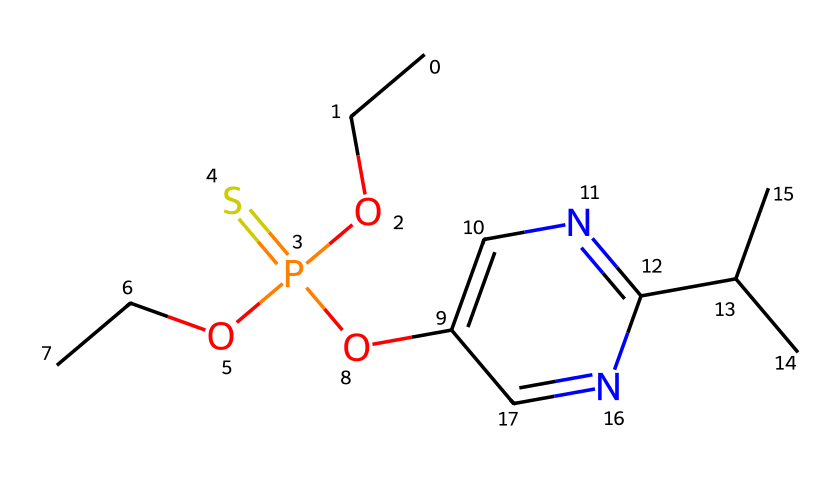How many carbon atoms are present in diazinon? By examining the SMILES representation, we can identify the carbon atoms, which are indicated by the letter "C." Counting all occurrences of "C" (including those in branches), we find there are a total of 10 carbon atoms in the structure.
Answer: 10 What functional group is present in diazinon? In the SMILES, the "O" and "P(=S)" portions indicate the presence of a phosphate functional group. This suggests the chemical belongs to organophosphates, characterized by phosphorus bonded to oxygen.
Answer: phosphate How many nitrogen atoms are present in diazinon? The "n" in the SMILES indicates nitrogen atoms. Observing the structure, we see there are two occurrences of "n," leading us to conclude that there are 2 nitrogen atoms.
Answer: 2 What is the molecular formula of diazinon? By counting the elements in the SMILES—10 carbons, 14 hydrogens, 2 nitrogens, 2 oxygens, 1 phosphorus, and 1 sulfur—we can construct the molecular formula. This leads to the conclusion that the molecular formula is C10H14N2O4PS.
Answer: C10H14N2O4PS What type of pesticide is diazinon classified as? Diazinon is classified as an organophosphate pesticide. This classification is based on the presence of the phosphate functional group, which is typical of organophosphate pesticides that inhibit acetylcholinesterase.
Answer: organophosphate What is the significance of the sulfur atom in diazinon? The sulfur atom in the structure typically indicates the presence of thio groups which can enhance the insecticidal properties of organophosphate compounds by impacting the molecular mechanisms of action.
Answer: enhances insecticidal properties What type of bonds are primarily found in diazinon? The structure of diazinon includes single and double bonds. Analyzing the connections, we predominantly find single bonds (between carbon and other atoms), along with one double bond (the =S with phosphorus), typical for organophosphates.
Answer: single and double bonds 